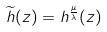<formula> <loc_0><loc_0><loc_500><loc_500>\widetilde { h } ( z ) = h ^ { \frac { \mu } { \lambda } } ( z )</formula> 